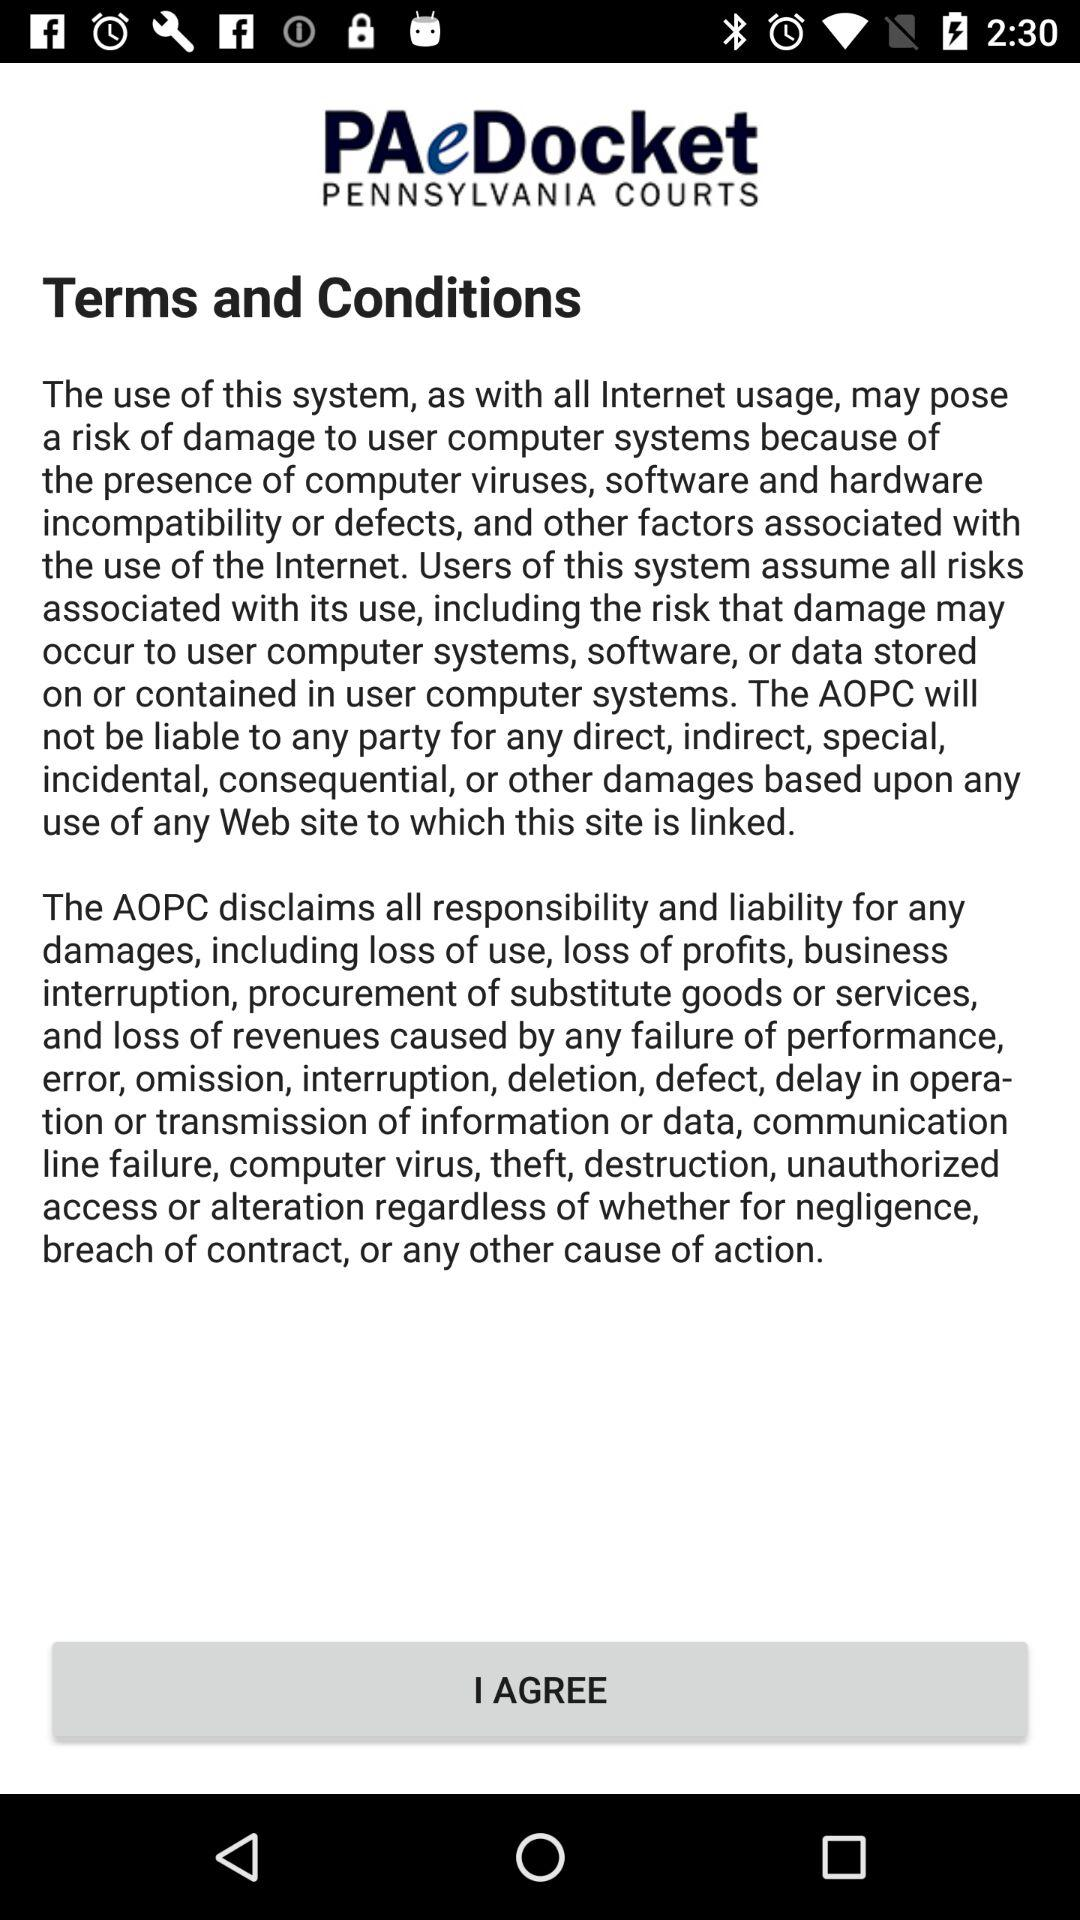What is the application name? The application name is "PAeDocket". 